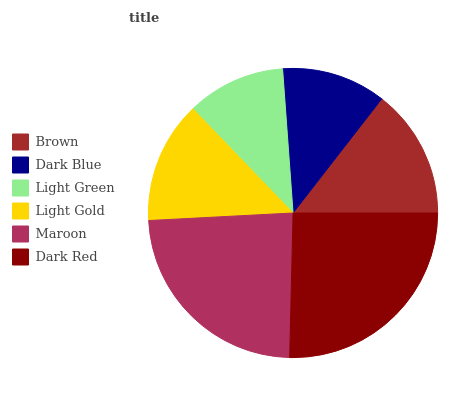Is Light Green the minimum?
Answer yes or no. Yes. Is Dark Red the maximum?
Answer yes or no. Yes. Is Dark Blue the minimum?
Answer yes or no. No. Is Dark Blue the maximum?
Answer yes or no. No. Is Brown greater than Dark Blue?
Answer yes or no. Yes. Is Dark Blue less than Brown?
Answer yes or no. Yes. Is Dark Blue greater than Brown?
Answer yes or no. No. Is Brown less than Dark Blue?
Answer yes or no. No. Is Brown the high median?
Answer yes or no. Yes. Is Light Gold the low median?
Answer yes or no. Yes. Is Dark Red the high median?
Answer yes or no. No. Is Light Green the low median?
Answer yes or no. No. 